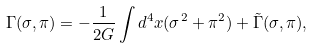Convert formula to latex. <formula><loc_0><loc_0><loc_500><loc_500>\Gamma ( \sigma , \pi ) = - \frac { 1 } { 2 G } \int d ^ { 4 } x ( \sigma ^ { 2 } + \pi ^ { 2 } ) + \tilde { \Gamma } ( \sigma , \pi ) ,</formula> 